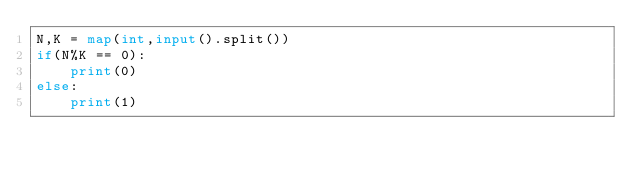Convert code to text. <code><loc_0><loc_0><loc_500><loc_500><_Python_>N,K = map(int,input().split())
if(N%K == 0):
    print(0)
else:
    print(1)</code> 